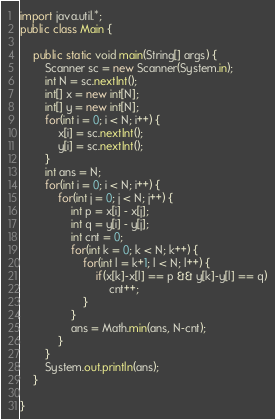Convert code to text. <code><loc_0><loc_0><loc_500><loc_500><_Java_>import java.util.*;
public class Main {

	public static void main(String[] args) {
		Scanner sc = new Scanner(System.in);
		int N = sc.nextInt();
		int[] x = new int[N];
		int[] y = new int[N];
		for(int i = 0; i < N; i++) {
			x[i] = sc.nextInt();
			y[i] = sc.nextInt();
		}
		int ans = N;
		for(int i = 0; i < N; i++) {
			for(int j = 0; j < N; j++) {
				int p = x[i] - x[j];
				int q = y[i] - y[j];
				int cnt = 0;
				for(int k = 0; k < N; k++) {
					for(int l = k+1; l < N; l++) {
						if(x[k]-x[l] == p && y[k]-y[l] == q)
							cnt++;
					}
				}
				ans = Math.min(ans, N-cnt);
			}
		}
		System.out.println(ans);
	}

}
</code> 